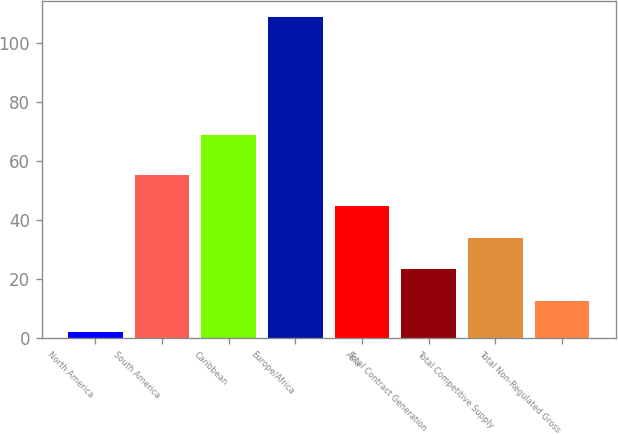Convert chart to OTSL. <chart><loc_0><loc_0><loc_500><loc_500><bar_chart><fcel>North America<fcel>South America<fcel>Caribbean<fcel>Europe/Africa<fcel>Asia<fcel>Total Contract Generation<fcel>Total Competitive Supply<fcel>Total Non-Regulated Gross<nl><fcel>2<fcel>55.5<fcel>69<fcel>109<fcel>44.8<fcel>23.4<fcel>34.1<fcel>12.7<nl></chart> 